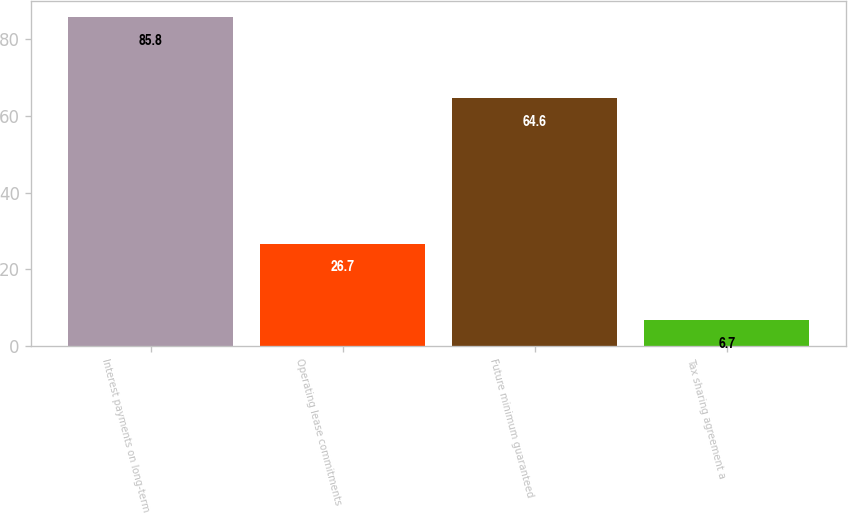Convert chart to OTSL. <chart><loc_0><loc_0><loc_500><loc_500><bar_chart><fcel>Interest payments on long-term<fcel>Operating lease commitments<fcel>Future minimum guaranteed<fcel>Tax sharing agreement a<nl><fcel>85.8<fcel>26.7<fcel>64.6<fcel>6.7<nl></chart> 